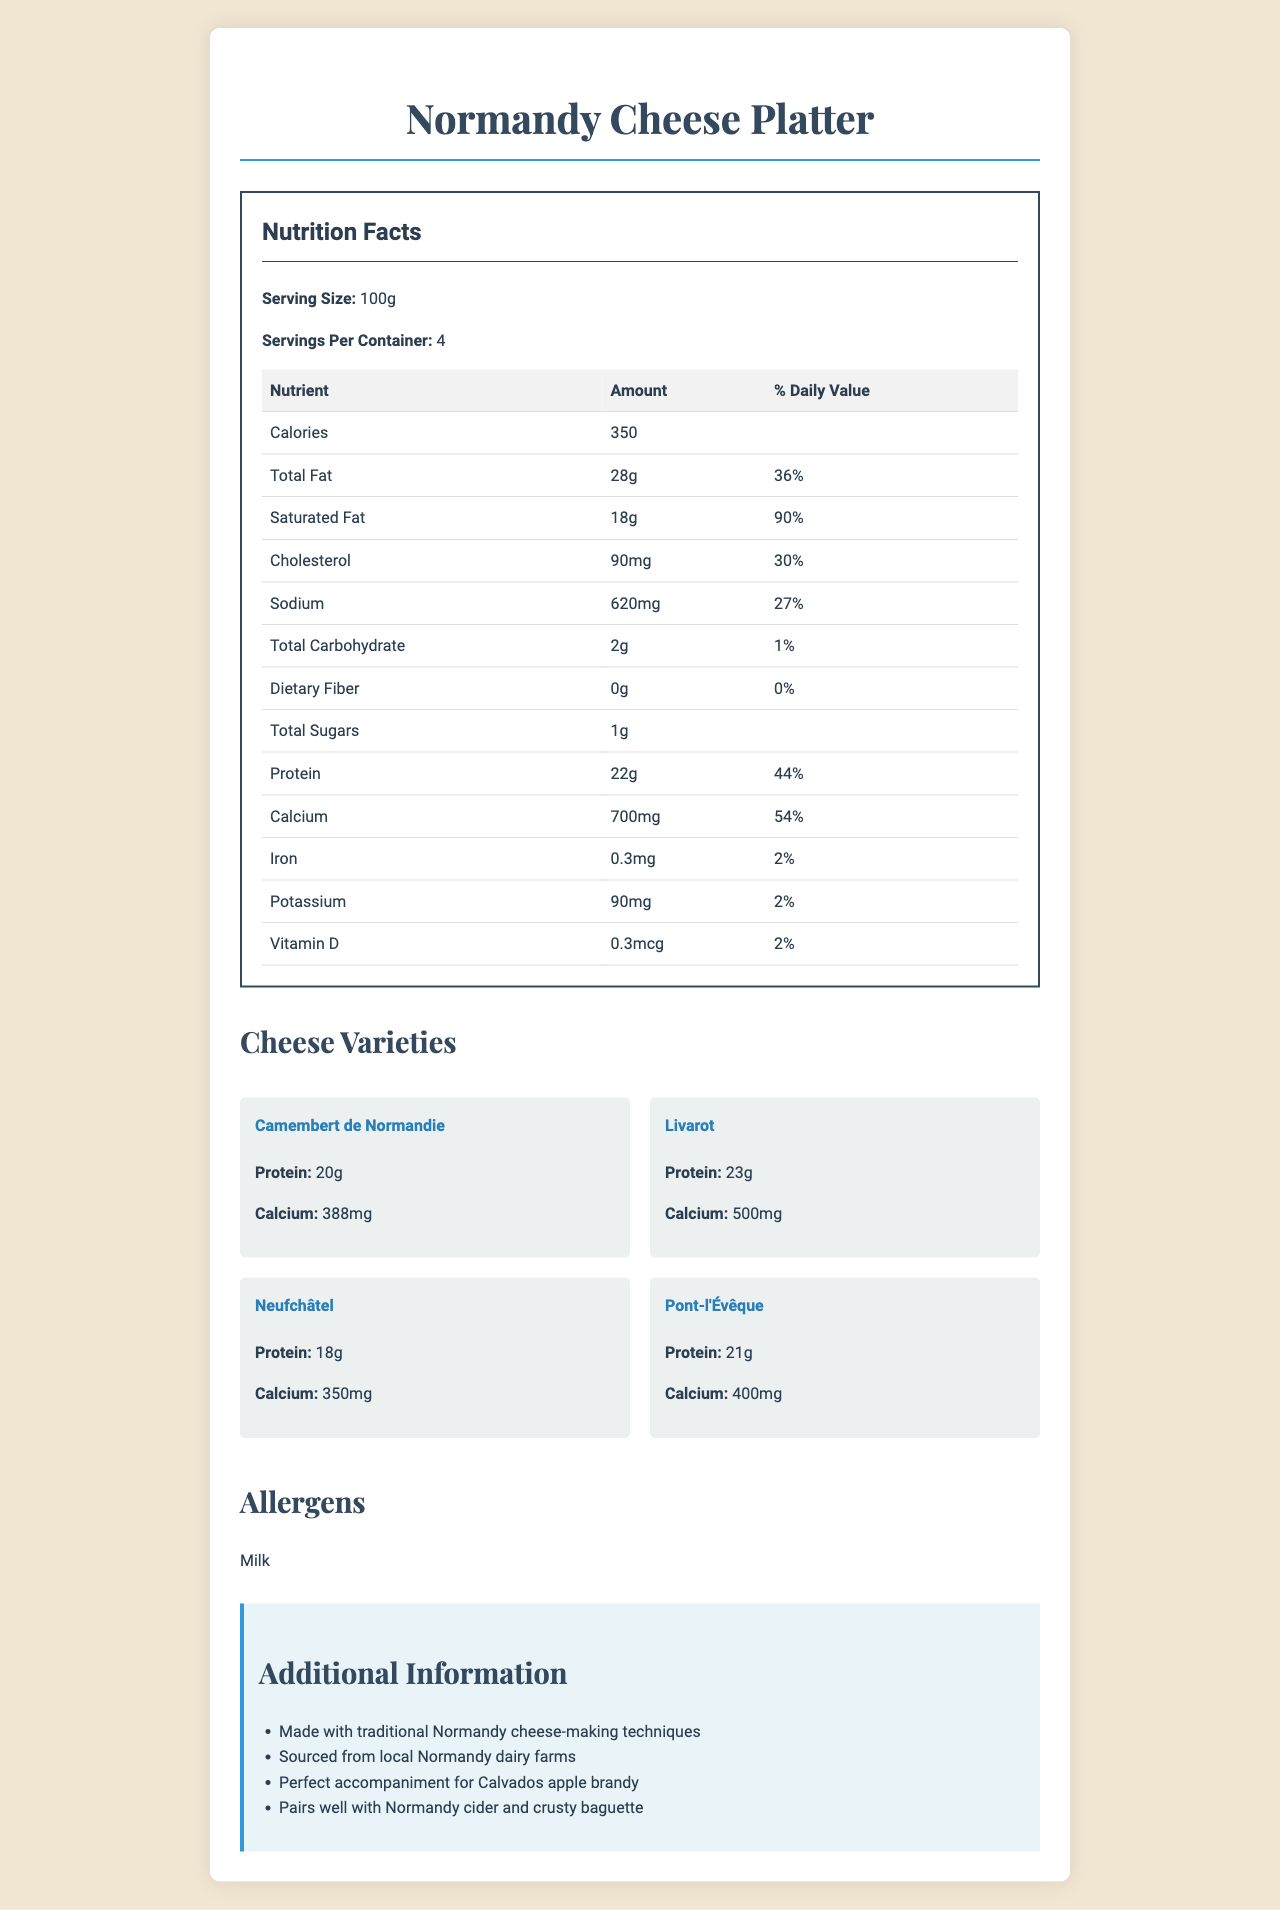How many servings are in the Normandy Cheese Platter? The document states that there are 4 servings per container.
Answer: 4 What is the amount of calcium per serving? The document lists the calcium content as 700mg.
Answer: 700mg Which cheese variety has the highest protein content? Livarot has 23g of protein, which is the highest among the listed cheeses.
Answer: Livarot What is the total fat percentage of daily value in one serving? The total fat content is 28g, accounting for 36% of the daily value.
Answer: 36% How much potassium is in one serving? The document lists the potassium amount as 90mg per serving.
Answer: 90mg Which of the following cheeses has the least amount of calcium? A. Camembert de Normandie B. Livarot C. Neufchâtel D. Pont-l'Évêque Neufchâtel has 350mg of calcium, which is the least among the listed cheeses.
Answer: C. Neufchâtel What is the daily value percentage of saturated fat in one serving? The document indicates that the saturated fat is 18g, which is 90% of the daily value.
Answer: 90% Does the Normandy Cheese Platter contain dietary fiber? The document states that the dietary fiber content is 0g.
Answer: No Is cholesterol content listed as one of the nutrients in the Normandy Cheese Platter? The document lists cholesterol content as 90mg, 30% of the daily value.
Answer: Yes Summarize the key points of the Nutrition Facts for the Normandy Cheese Platter. The document provides nutritional information, ingredients, and additional details about the cheese varieties and the allergens present in the product.
Answer: Key points include: Serving size is 100g with 4 servings per container, 350 calories, and key nutrients including 28g of total fat (36% DV), 22g of protein (44% DV), and 700mg of calcium (54% DV). What is the recommended serving size for the Normandy Cheese Platter? The document states that the serving size is 100g.
Answer: 100g Which cheese variety has the highest calcium content? Livarot has 500mg of calcium, the highest among the listed cheeses.
Answer: Livarot Can you determine where the cheeses are sourced from based on this document? The document specifies that the cheeses are sourced from local Normandy dairy farms.
Answer: Normandy dairy farms What pairs well with the cheeses according to the document? The additional information section mentions these items as good pairings with the cheeses.
Answer: Calvados apple brandy, Normandy cider, and crusty baguette How much total carbohydrate is in each serving? The document provides that the total carbohydrate per serving is 2g.
Answer: 2g Among these cheese varieties, which has the lowest protein content? A. Camembert de Normandie B. Livarot C. Neufchâtel D. Pont-l'Évêque Neufchâtel has 18g of protein, which is the lowest among the listed cheese varieties.
Answer: C. Neufchâtel What percentage of daily value is the sodium content? The sodium content is 620mg, which represents 27% of the daily value.
Answer: 27% Describe the allergens present in the Normandy Cheese Platter. The document lists milk as the allergen.
Answer: Milk What is the percentage daily value of iron in one serving? The document states that iron is present at 0.3mg, which is 2% of the daily value.
Answer: 2% Which cheese variety has the highest calcium content? A. Camembert de Normandie B. Livarot C. Neufchâtel D. Pont-l'Évêque Livarot has the highest calcium content at 500mg.
Answer: B. Livarot 